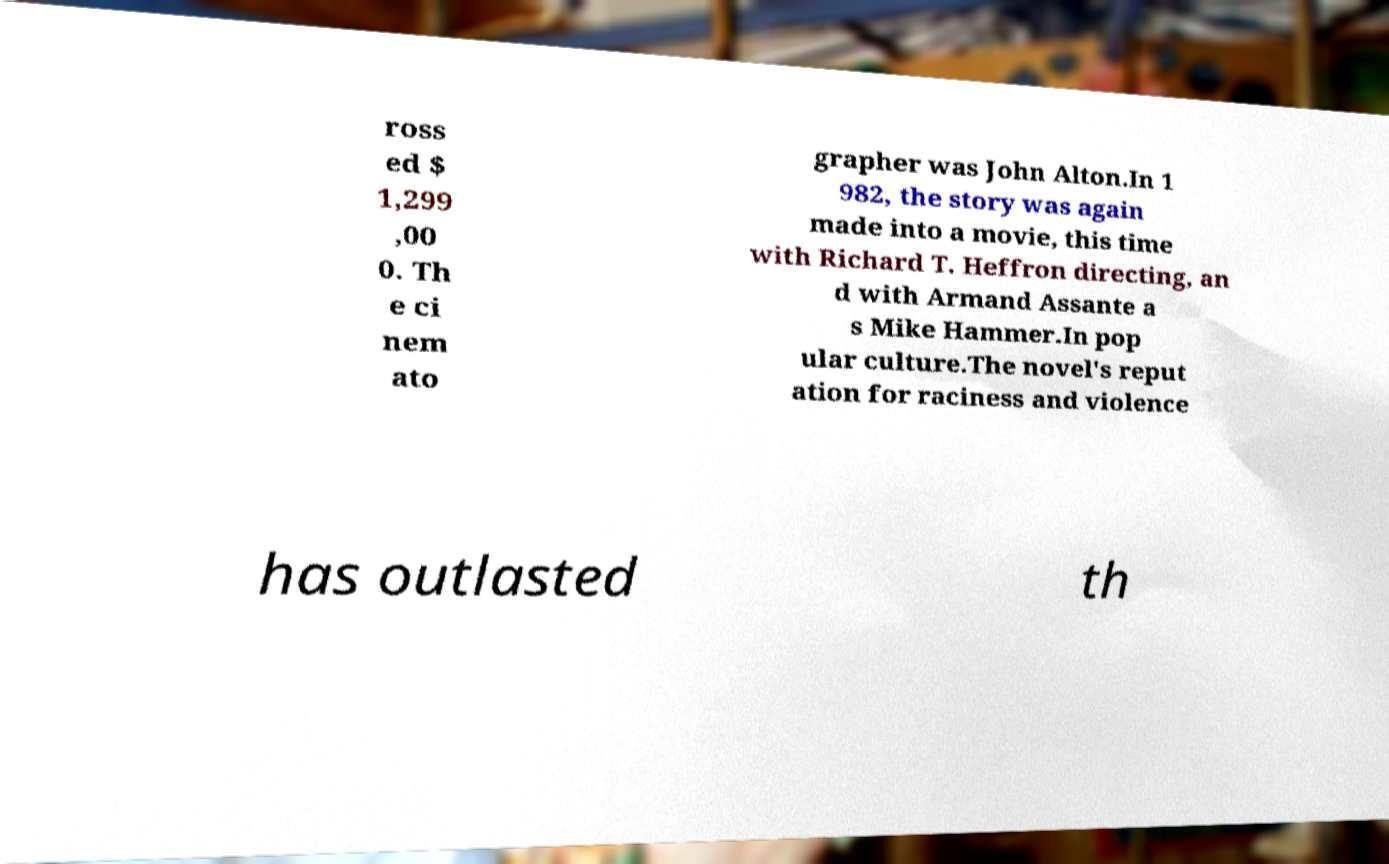There's text embedded in this image that I need extracted. Can you transcribe it verbatim? ross ed $ 1,299 ,00 0. Th e ci nem ato grapher was John Alton.In 1 982, the story was again made into a movie, this time with Richard T. Heffron directing, an d with Armand Assante a s Mike Hammer.In pop ular culture.The novel's reput ation for raciness and violence has outlasted th 